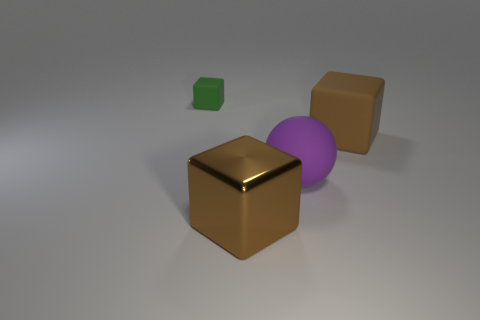Is there any other thing that has the same shape as the purple matte thing?
Offer a terse response. No. What size is the thing behind the big brown object that is behind the brown metal object?
Your response must be concise. Small. Is the number of brown matte cubes that are behind the tiny object the same as the number of tiny matte things that are left of the brown rubber cube?
Keep it short and to the point. No. Is there anything else that has the same size as the green matte block?
Offer a terse response. No. What color is the large block that is the same material as the purple ball?
Provide a short and direct response. Brown. Does the purple sphere have the same material as the large brown cube in front of the matte ball?
Your answer should be compact. No. What is the color of the thing that is both to the right of the small cube and behind the purple rubber thing?
Offer a very short reply. Brown. How many blocks are either small green rubber things or big purple matte objects?
Your response must be concise. 1. Does the small thing have the same shape as the brown object behind the big brown metallic cube?
Provide a succinct answer. Yes. What size is the thing that is on the left side of the big ball and in front of the tiny object?
Your answer should be very brief. Large. 